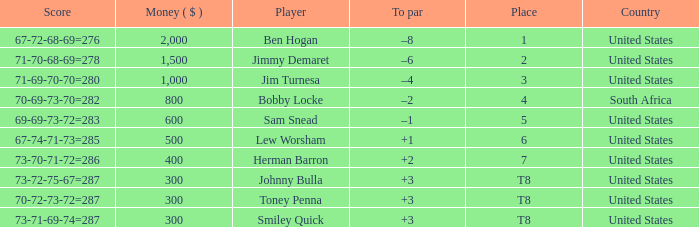What is the 4th place player's to par score? –2. 